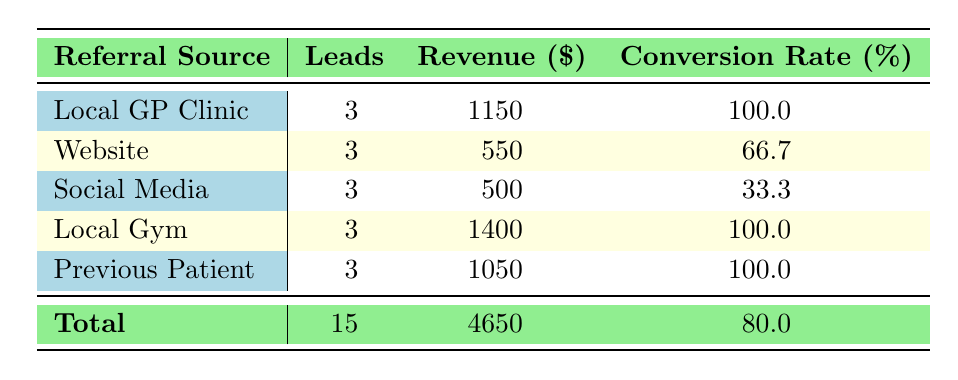How many new patient leads came from the Local Gym? The table shows that the Local Gym had 3 leads listed under the 'Leads' column.
Answer: 3 What was the total revenue generated from patients referred by Previous Patients? The table indicates that the Previous Patient source generated a revenue of 1050, as shown in the 'Revenue' column.
Answer: 1050 What is the conversion rate for referrals from Social Media? The 'Conversion Rate' column for Social Media shows a conversion rate of 33.3%, which is directly stated in the table.
Answer: 33.3 Which referral source had the highest revenue, and what was that revenue? Reviewing the 'Revenue' column indicates that the Local Gym had the highest revenue at 1400.
Answer: Local Gym, 1400 What is the average revenue from all referral sources? To find the average revenue, sum all revenues (1150 + 550 + 500 + 1400 + 1050 = 4150) and divide by the number of sources (5), which gives an average of 4150 / 5 = 830.
Answer: 830 Is the conversion rate for Website referrals more than 60%? The table shows that the conversion rate for Website referrals is 66.7%, which is indeed more than 60%.
Answer: Yes What is the total number of leads across all referral sources? The 'Leads' column shows a total of 15 by simply adding all the leads from each referral source (3 from each source amounts to 15 total leads).
Answer: 15 Did all referral sources lead to patient conversions? A review of the 'Conversion Rate' column reveals that Social Media has a conversion rate of 33.3%, indicating there were leads that did not result in conversions.
Answer: No Which referral source or sources generated the least amount of revenue, and what was that revenue? By looking at the revenue amounts, Social Media generated the least at 500 among the sources listed, as it is the lowest value in the 'Revenue' column.
Answer: Social Media, 500 